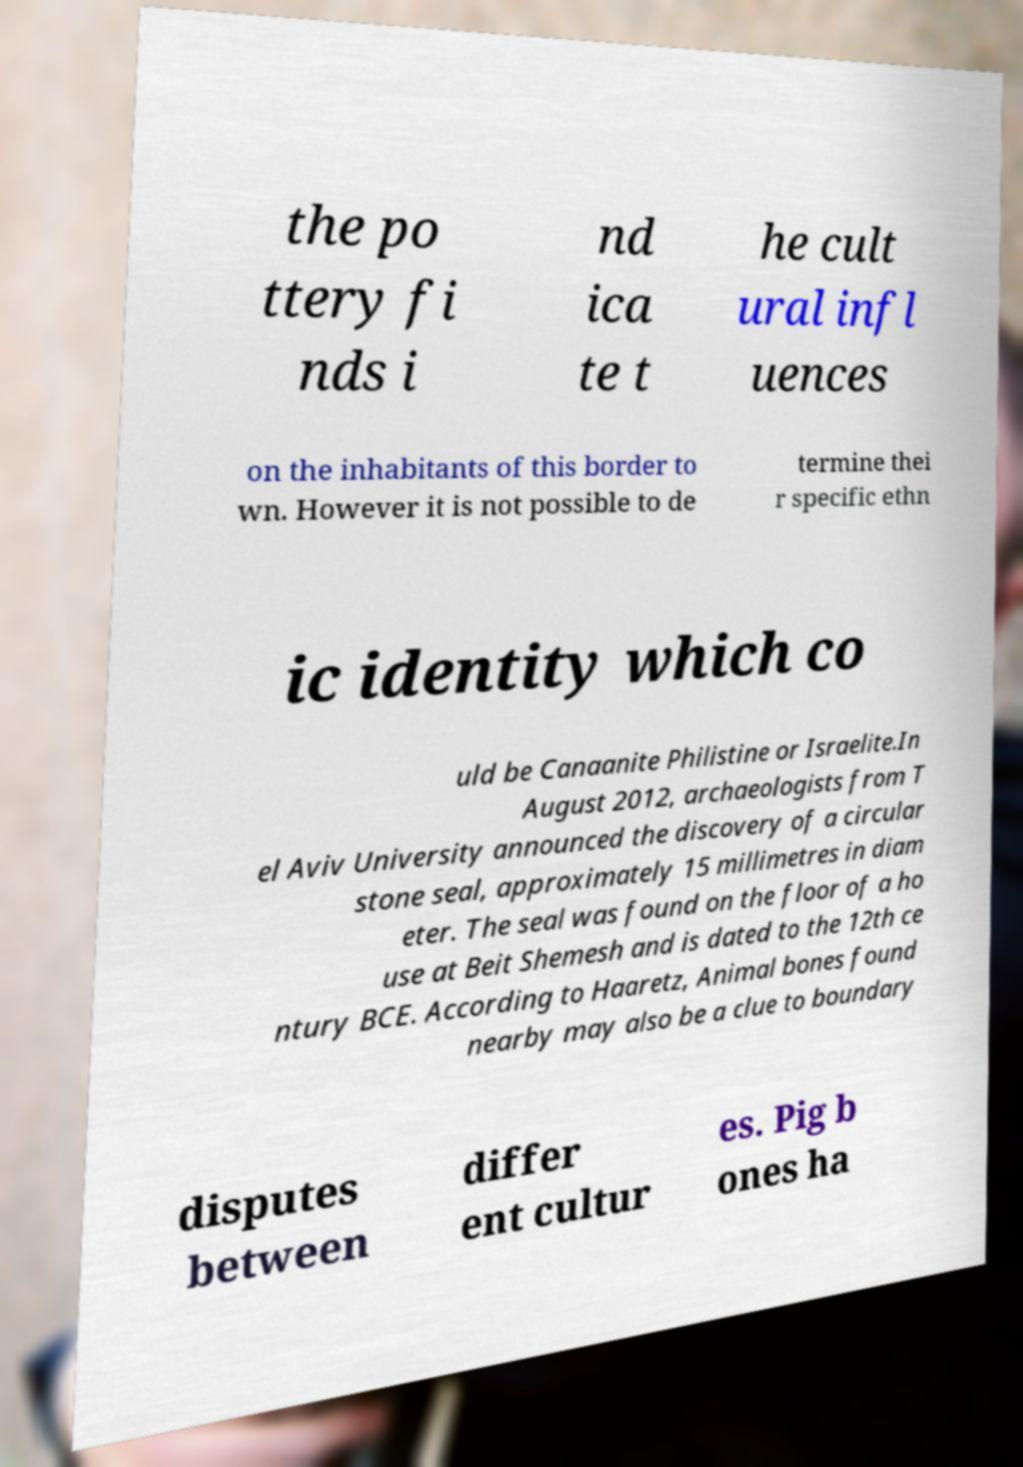There's text embedded in this image that I need extracted. Can you transcribe it verbatim? the po ttery fi nds i nd ica te t he cult ural infl uences on the inhabitants of this border to wn. However it is not possible to de termine thei r specific ethn ic identity which co uld be Canaanite Philistine or Israelite.In August 2012, archaeologists from T el Aviv University announced the discovery of a circular stone seal, approximately 15 millimetres in diam eter. The seal was found on the floor of a ho use at Beit Shemesh and is dated to the 12th ce ntury BCE. According to Haaretz, Animal bones found nearby may also be a clue to boundary disputes between differ ent cultur es. Pig b ones ha 